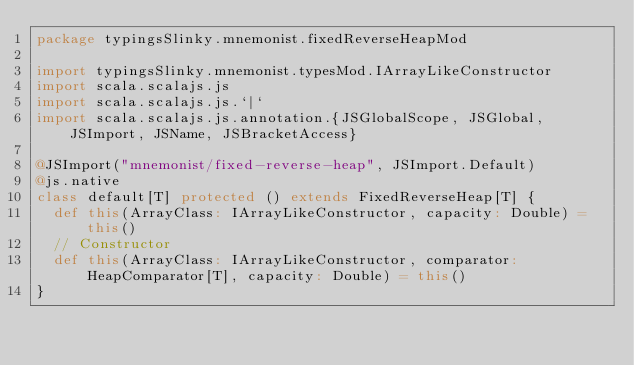Convert code to text. <code><loc_0><loc_0><loc_500><loc_500><_Scala_>package typingsSlinky.mnemonist.fixedReverseHeapMod

import typingsSlinky.mnemonist.typesMod.IArrayLikeConstructor
import scala.scalajs.js
import scala.scalajs.js.`|`
import scala.scalajs.js.annotation.{JSGlobalScope, JSGlobal, JSImport, JSName, JSBracketAccess}

@JSImport("mnemonist/fixed-reverse-heap", JSImport.Default)
@js.native
class default[T] protected () extends FixedReverseHeap[T] {
  def this(ArrayClass: IArrayLikeConstructor, capacity: Double) = this()
  // Constructor
  def this(ArrayClass: IArrayLikeConstructor, comparator: HeapComparator[T], capacity: Double) = this()
}
</code> 